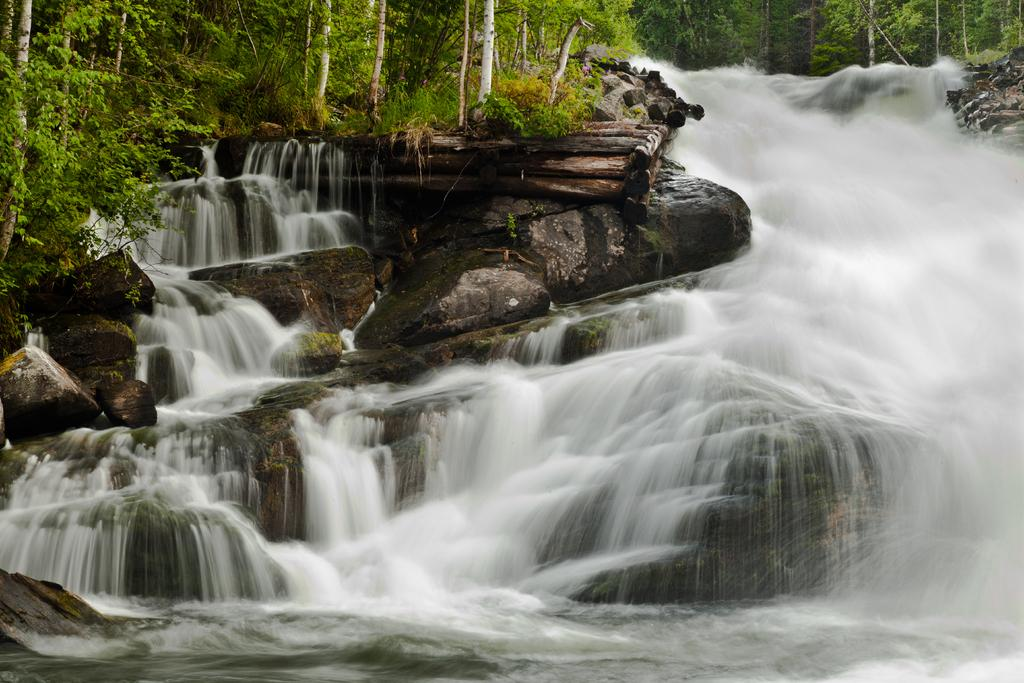What natural feature is the main subject of the picture? There is a waterfall in the picture. What can be seen in the background of the picture? There are rocks and trees in the background of the picture. What type of ball is being used by the goose in the picture? There is no goose or ball present in the picture; it features a waterfall with rocks and trees in the background. 